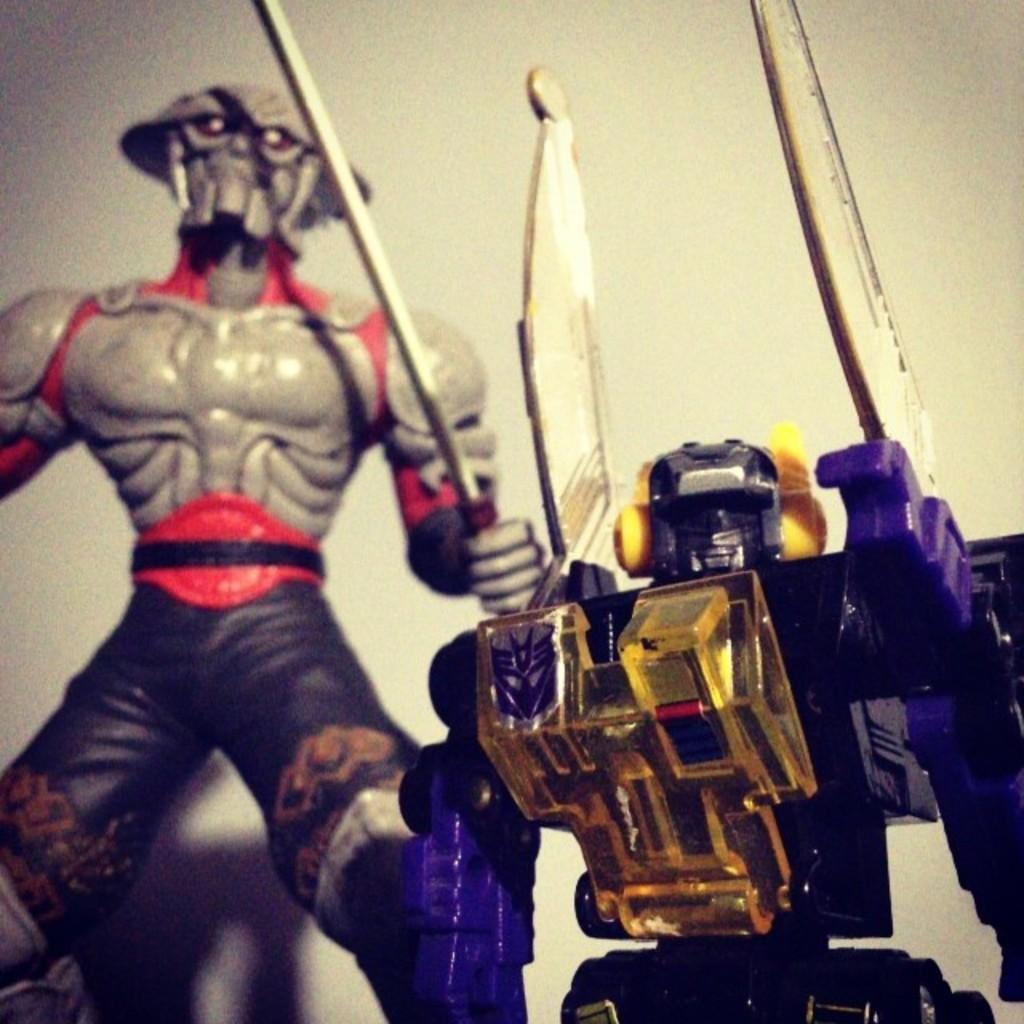How many toys are present in the image? There are two toys in the image. What can be seen in the background of the image? There is a wall in the background of the image. What color is the bath in the image? There is no bath present in the image. 